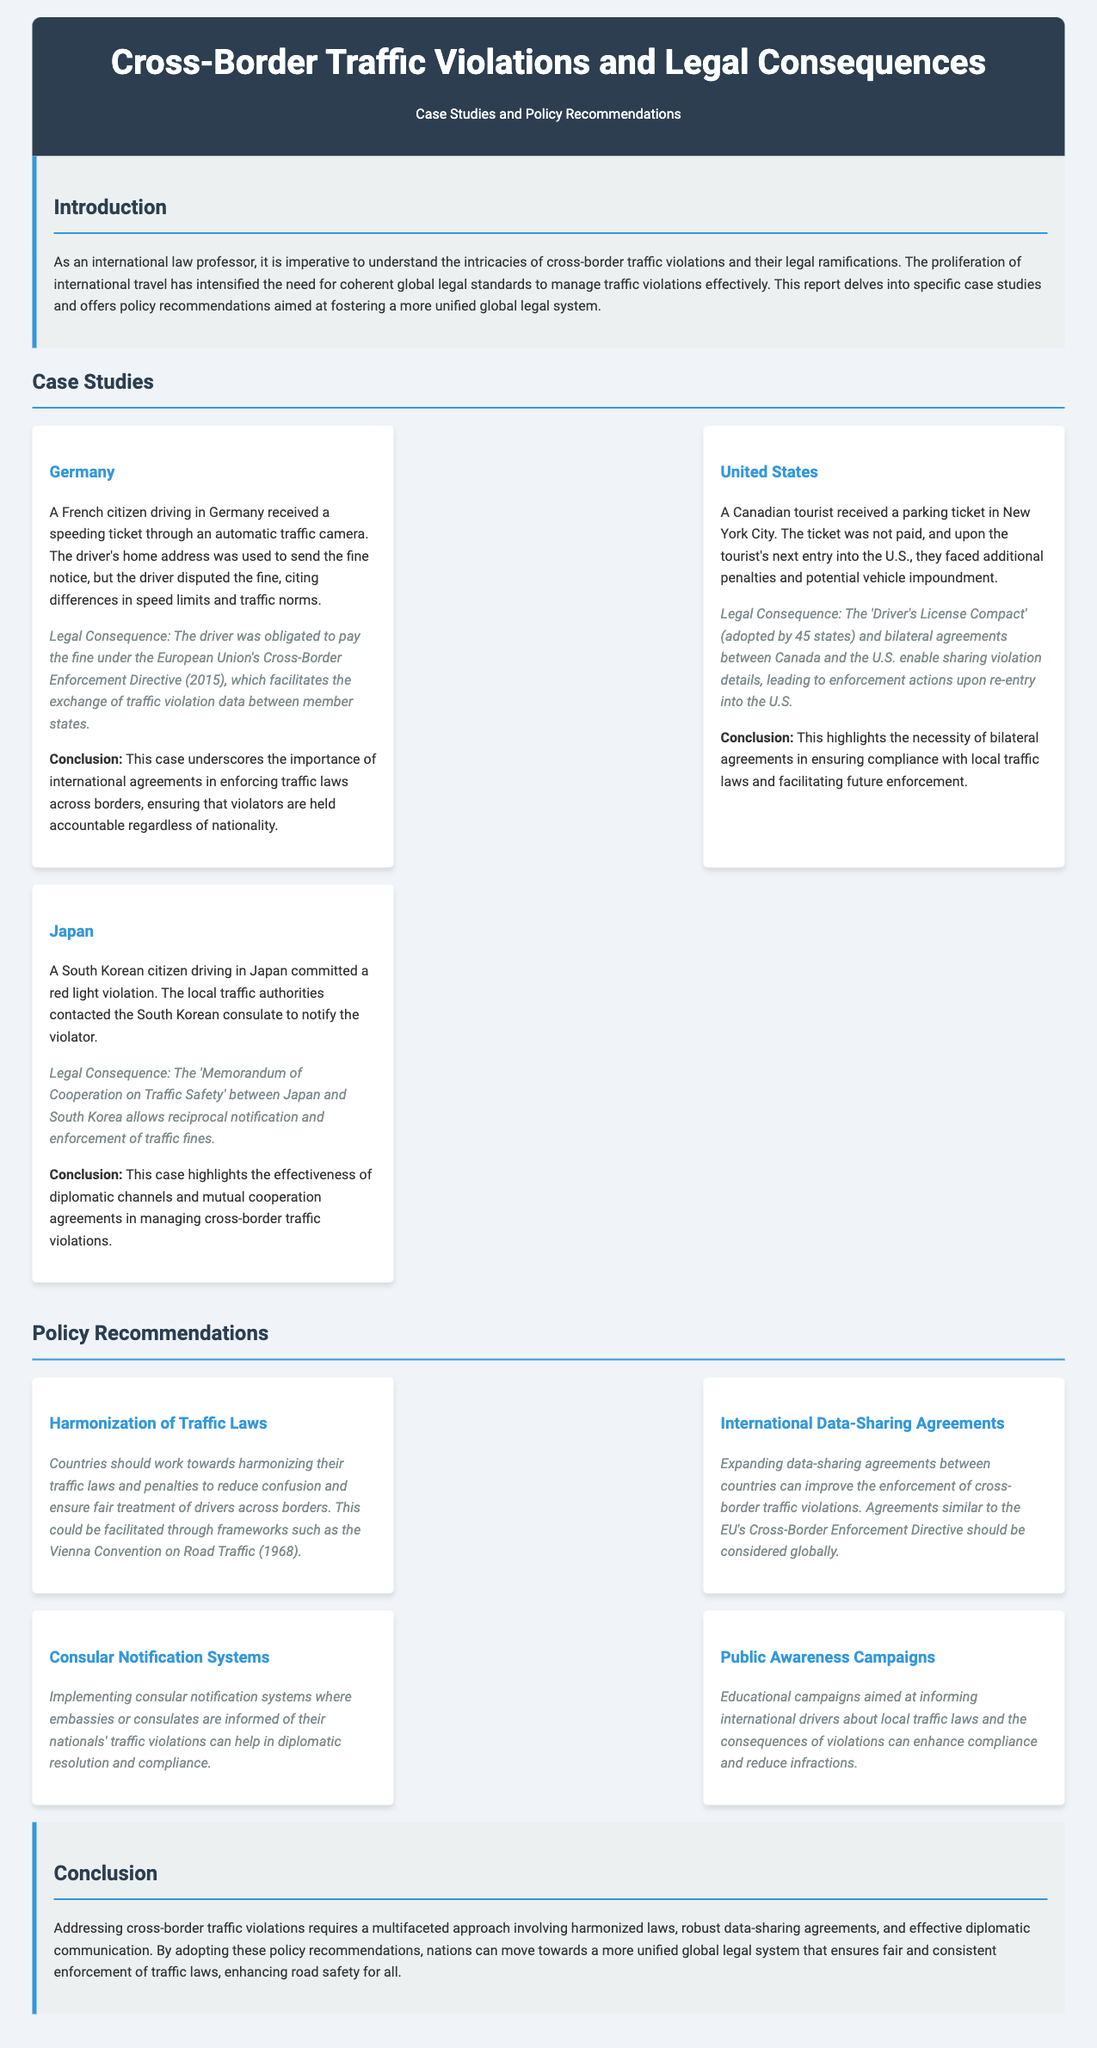What was the speeding violation case country? The case involving a speeding violation was about a French citizen driving in Germany.
Answer: Germany Who received a parking ticket in New York City? A Canadian tourist received a parking ticket in New York City.
Answer: Canadian tourist What agreement facilitates data sharing for traffic violations between Canada and the U.S.? The 'Driver's License Compact' enables sharing violation details.
Answer: Driver's License Compact What legal document is suggested for harmonizing traffic laws? The Vienna Convention on Road Traffic (1968) is suggested for harmonization.
Answer: Vienna Convention on Road Traffic (1968) What is one of the policy recommendations regarding educational efforts? Educational campaigns aimed at informing international drivers about local traffic laws are recommended.
Answer: Public Awareness Campaigns What type of cooperation exists between Japan and South Korea regarding traffic fines? The 'Memorandum of Cooperation on Traffic Safety' allows reciprocal notification and enforcement.
Answer: Memorandum of Cooperation on Traffic Safety How many states adopted the 'Driver's License Compact'? Forty-five states have adopted the 'Driver's License Compact'.
Answer: 45 What is emphasized as necessary for future enforcement compliance? The necessity of bilateral agreements is emphasized for future enforcement.
Answer: Bilateral agreements What section in the report contains the conclusion? The conclusion is contained in the last section titled "Conclusion".
Answer: Conclusion 